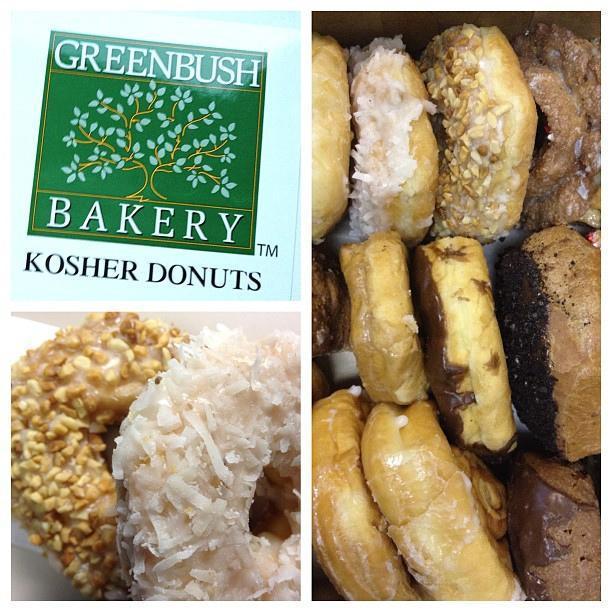How many donuts can you see?
Give a very brief answer. 12. 